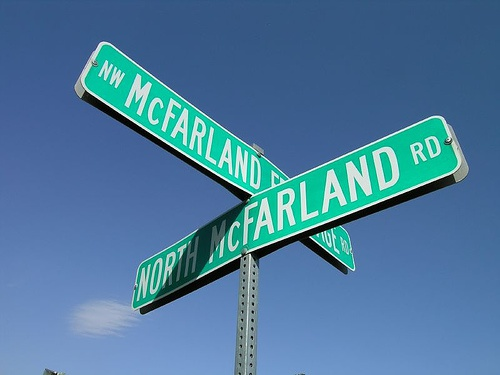Describe the objects in this image and their specific colors. I can see various objects in this image with different colors. 